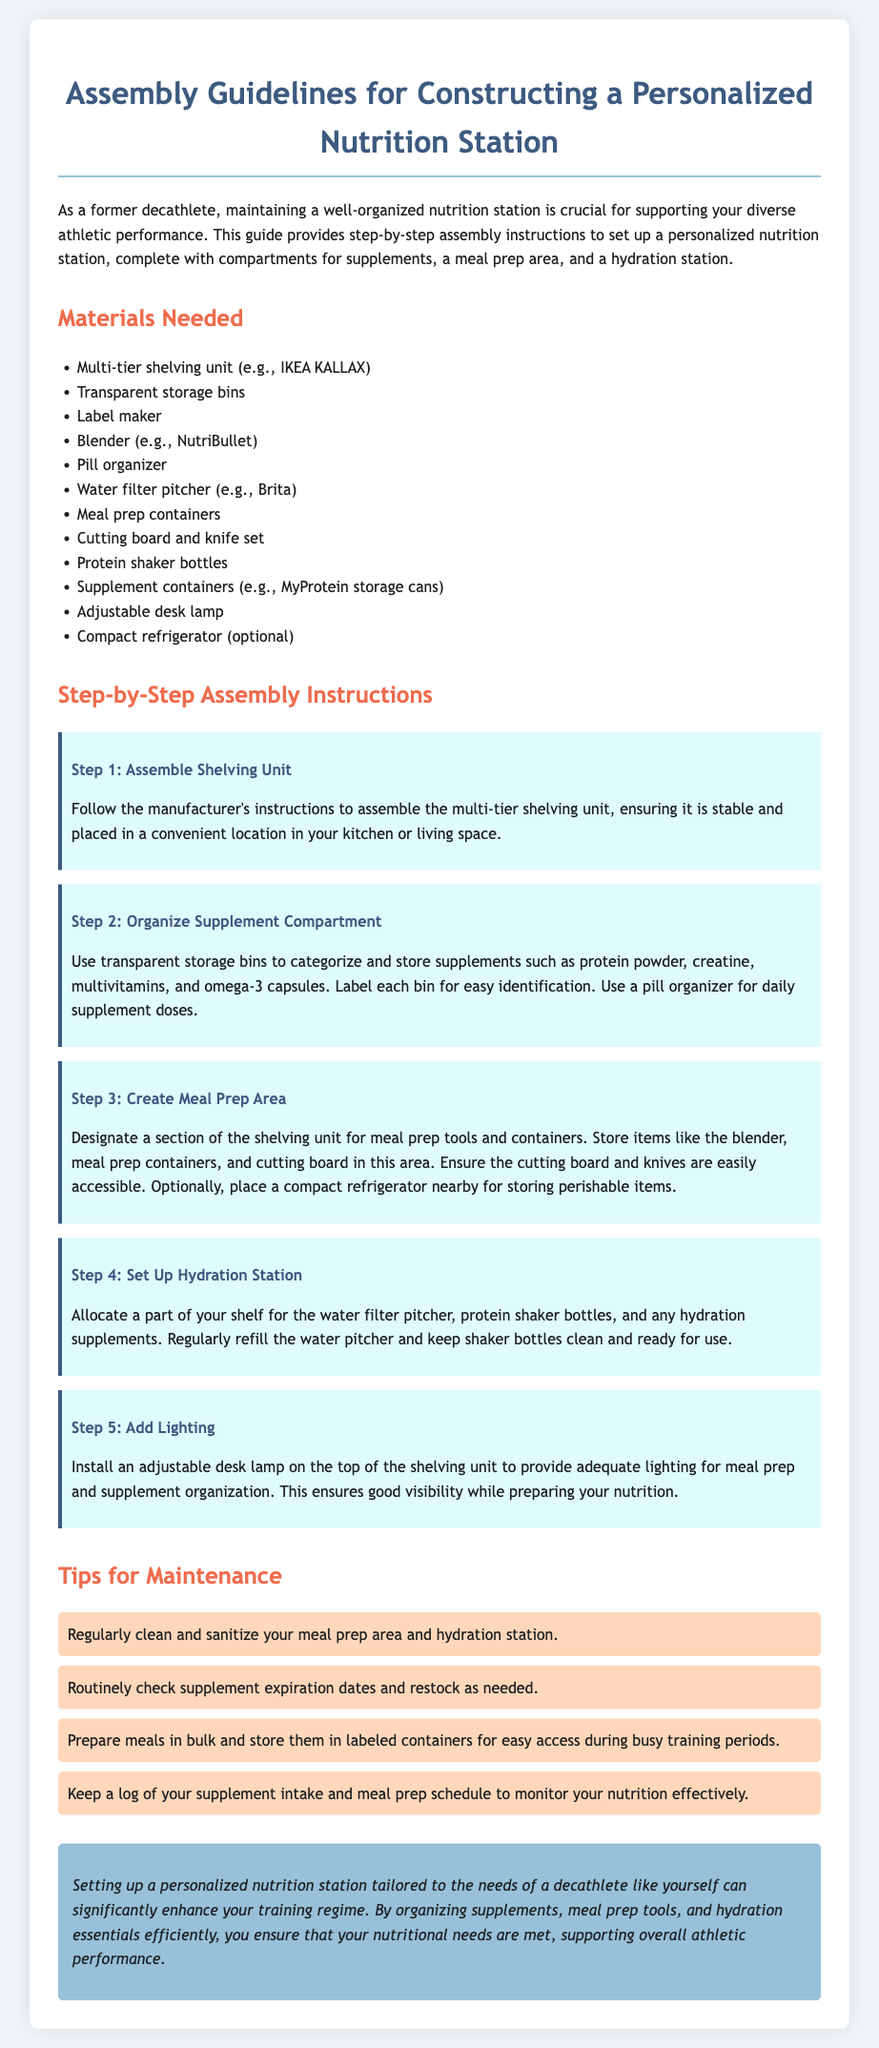What is the main purpose of the document? The main purpose of the document is to provide assembly guidelines for constructing a personalized nutrition station that supports athletic performance.
Answer: Supporting athletic performance How many steps are included in the assembly instructions? The document presents five steps in the assembly instructions for setting up the nutrition station.
Answer: Five steps What type of shelving unit is suggested? The suggested shelving unit for the nutrition station is a multi-tier shelving unit, specifically an IKEA KALLAX.
Answer: IKEA KALLAX What is recommended for keeping daily supplements organized? A pill organizer is recommended for keeping daily supplements organized and easily accessible.
Answer: Pill organizer What should be installed on top of the shelving unit? An adjustable desk lamp should be installed on top of the shelving unit to provide adequate lighting for meal prep.
Answer: Adjustable desk lamp What is an optional item for storing perishable items? A compact refrigerator is mentioned as an optional item for storing perishable items near the meal prep area.
Answer: Compact refrigerator What should be done regularly to maintain the hydration station? The water pitcher should be regularly refilled to maintain the hydration station's effectiveness.
Answer: Regularly refill the water pitcher Which tool is used for meal prep in the designated area? The tool used for meal prep in the designated area is a blender.
Answer: Blender What is advised for bulk meal preparation? Preparing meals in bulk and storing them in labeled containers is advised for easy access during busy training periods.
Answer: Prepare meals in bulk 